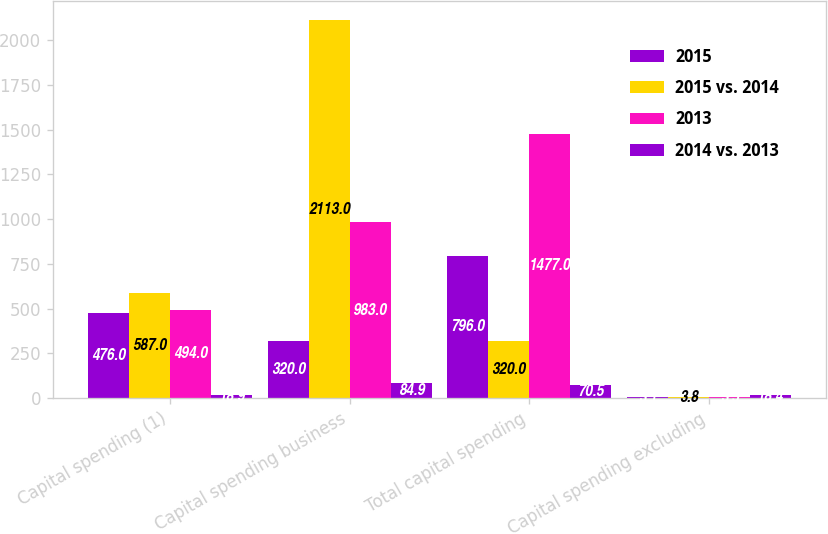<chart> <loc_0><loc_0><loc_500><loc_500><stacked_bar_chart><ecel><fcel>Capital spending (1)<fcel>Capital spending business<fcel>Total capital spending<fcel>Capital spending excluding<nl><fcel>2015<fcel>476<fcel>320<fcel>796<fcel>3.1<nl><fcel>2015 vs. 2014<fcel>587<fcel>2113<fcel>320<fcel>3.8<nl><fcel>2013<fcel>494<fcel>983<fcel>1477<fcel>3.5<nl><fcel>2014 vs. 2013<fcel>18.9<fcel>84.9<fcel>70.5<fcel>18.4<nl></chart> 